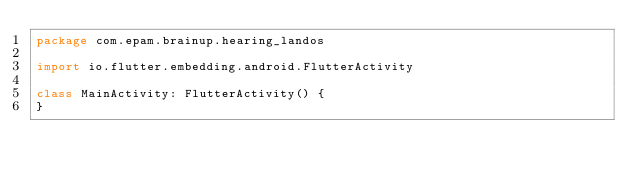<code> <loc_0><loc_0><loc_500><loc_500><_Kotlin_>package com.epam.brainup.hearing_landos

import io.flutter.embedding.android.FlutterActivity

class MainActivity: FlutterActivity() {
}
</code> 